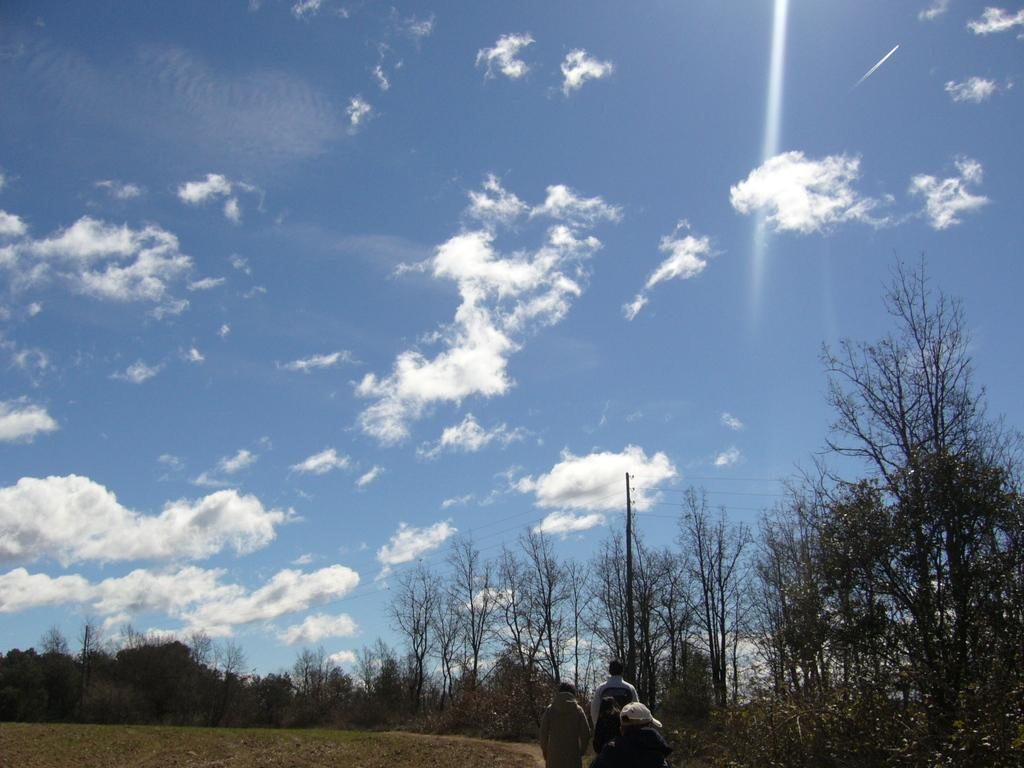How many people are in the image? There are two persons standing in the image. What are the people wearing? The persons are wearing clothes. What can be seen in the bottom right corner of the image? There are trees in the bottom right of the image. What is visible in the background of the image? There is a sky visible in the background of the image. Can you tell me which person is the sister of the other person in the image? There is no information provided about the relationship between the two persons in the image, so it cannot be determined if one is the sister of the other. 